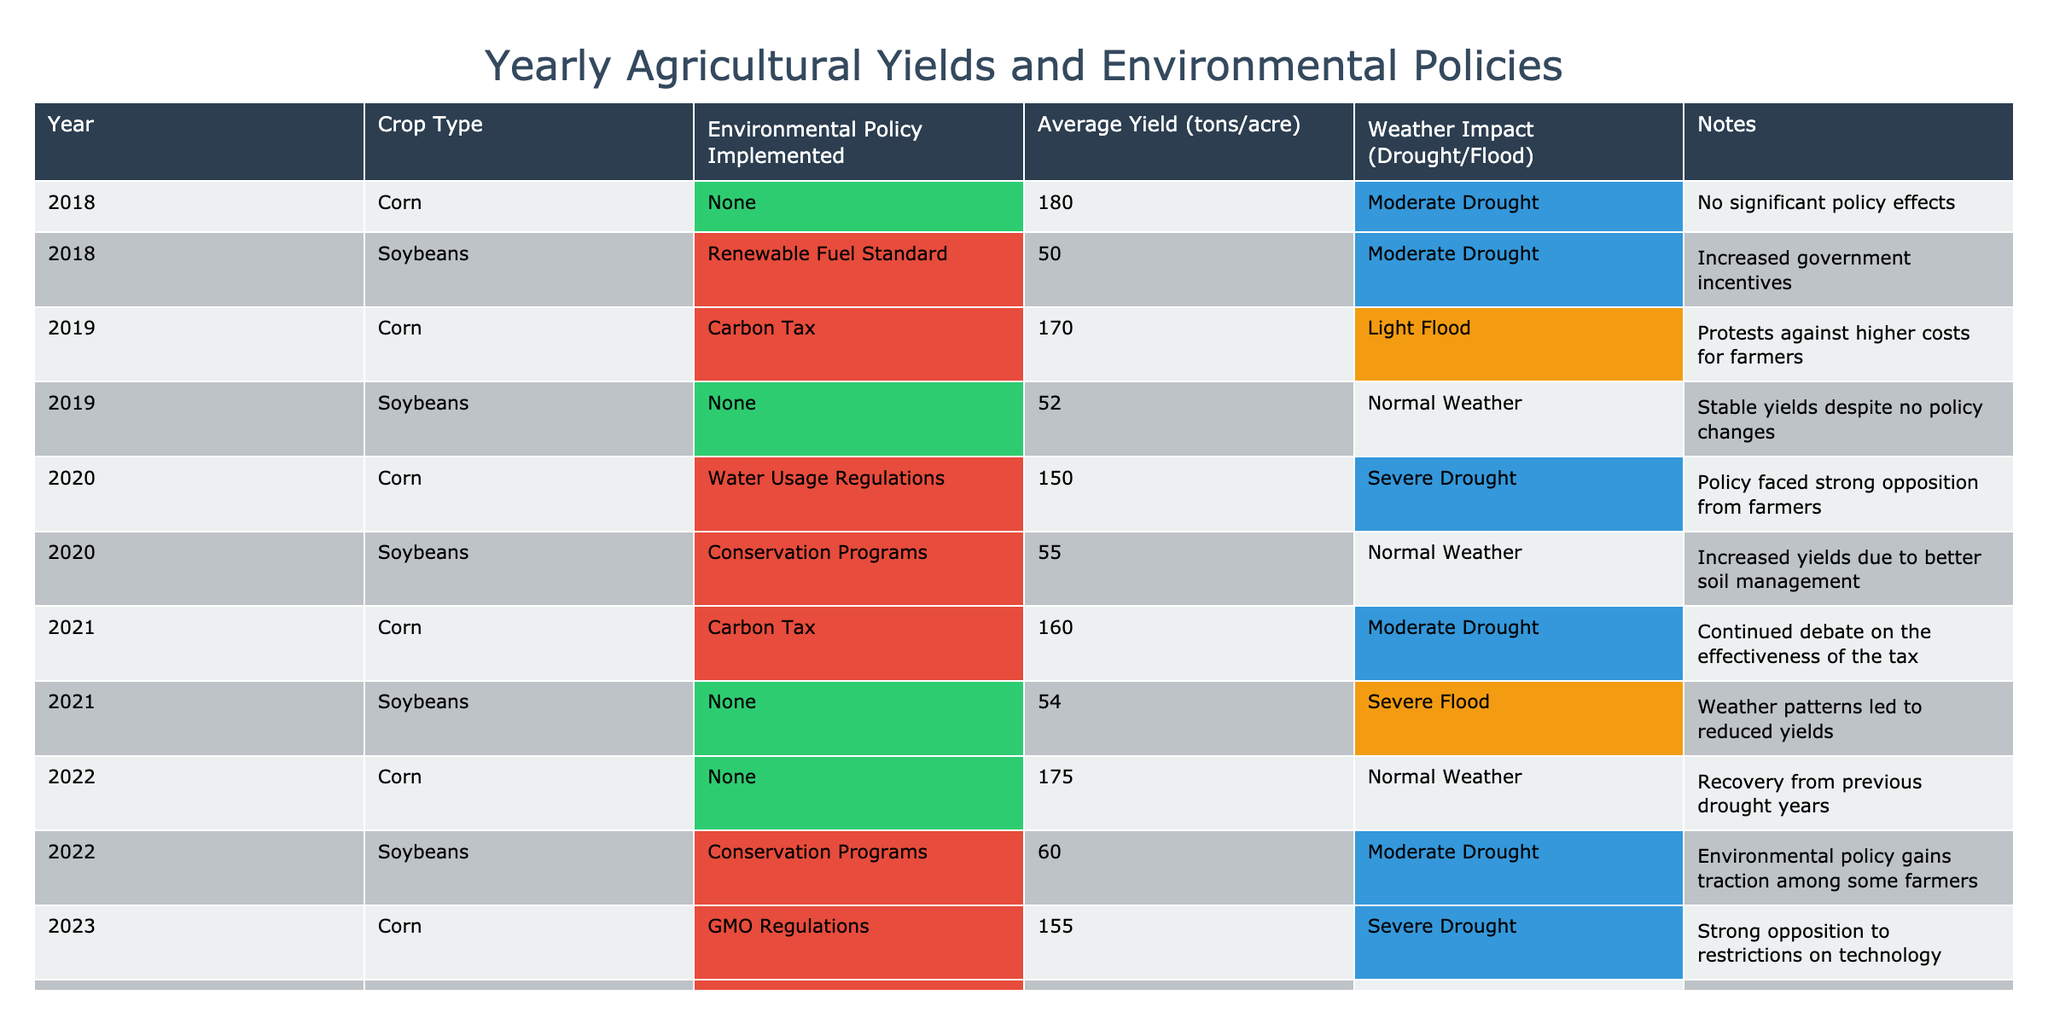What was the average yield of corn in 2020? In 2020, the average yield for corn was provided in the row corresponding to that year. Checking the table, it shows that the average yield for corn in 2020 was 150 tons per acre.
Answer: 150 tons/acre Which year had the highest average yield for soybeans? Looking through the table for the average yields of soybeans per year, I find the values: 50 (2018), 52 (2019), 55 (2020), 54 (2021), 60 (2022), and 58 (2023). The highest yield among these is 60 tons per acre in 2022.
Answer: 2022 Did the implementation of the Carbon Tax in 2019 result in a higher corn yield compared to 2018? For corn in 2019, the yield was 170 tons per acre with the Carbon Tax, while in 2018, under no policy, it was 180 tons per acre. Therefore, the yield in 2019 was lower than in 2018.
Answer: No What is the total yield for soybeans across all reported years? The average yields for soybeans by year are: 50 (2018), 52 (2019), 55 (2020), 54 (2021), 60 (2022), and 58 (2023). Adding these yields together results in 50 + 52 + 55 + 54 + 60 + 58 = 329 tons per acre.
Answer: 329 tons/acre In which year was the strongest weather impact recorded, and what was it? The weather impacts described include "Moderate Drought," "Light Flood," "Severe Drought," "Normal Weather," "Severe Flood," and "Normal Weather." The strongest impact is categorized as "Severe Drought," which occurred in 2020 and 2023.
Answer: 2020 and 2023 with "Severe Drought" Was there a year when both crops had higher yields with any environmental policy implemented? Analyzing the data, in 2022, corn yielded 175 tons/acre with no policy, and soybeans yielded 60 tons/acre with Conservation Programs. Therefore, both did not have higher yields with environmental policy in the same year; the corn yield was higher without a policy.
Answer: No 